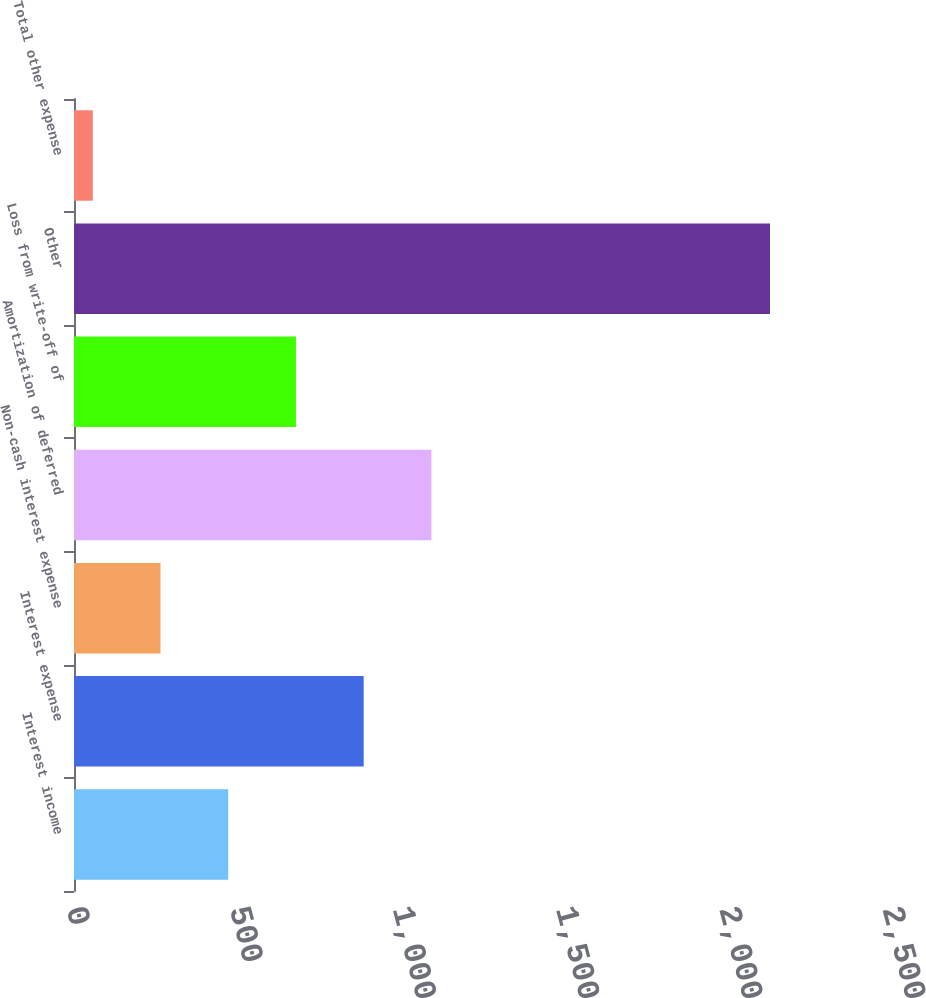Convert chart. <chart><loc_0><loc_0><loc_500><loc_500><bar_chart><fcel>Interest income<fcel>Interest expense<fcel>Non-cash interest expense<fcel>Amortization of deferred<fcel>Loss from write-off of<fcel>Other<fcel>Total other expense<nl><fcel>472.54<fcel>887.48<fcel>265.07<fcel>1094.95<fcel>680.01<fcel>2132.3<fcel>57.6<nl></chart> 